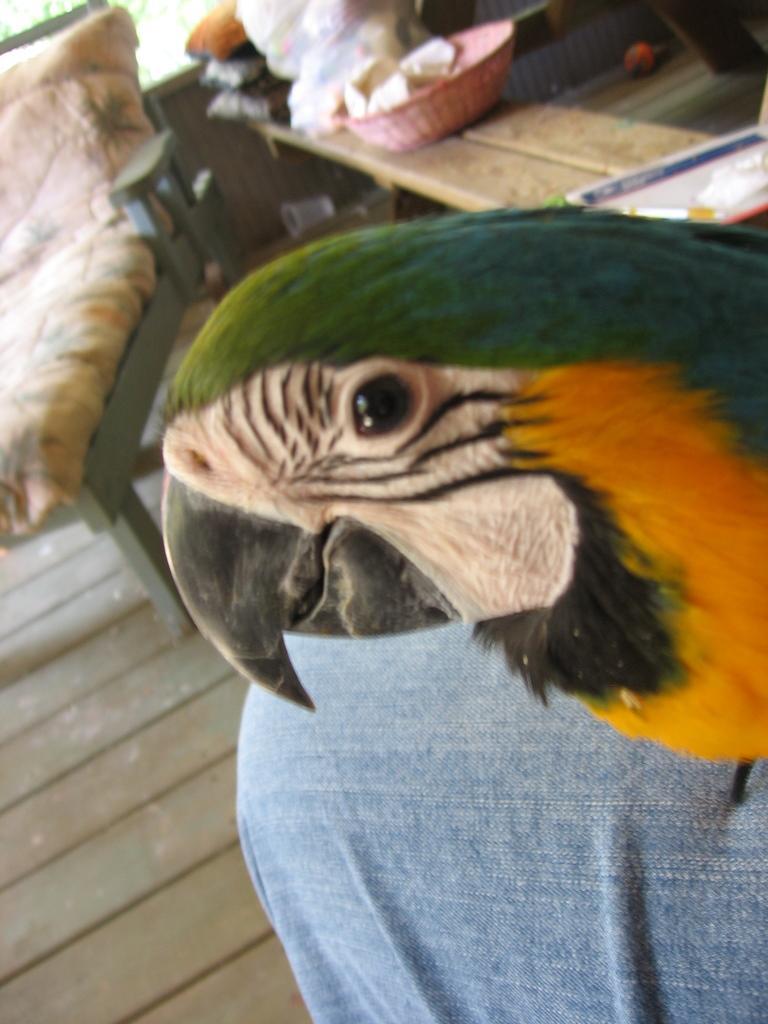Please provide a concise description of this image. This image is taken outdoors. On the left side of the image there is a floor and there is a couch. In the background there is a table with a basket and a few objects on it. There are a few things on the floor. On the right side of the image there is a person and there is a parrot. 